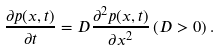Convert formula to latex. <formula><loc_0><loc_0><loc_500><loc_500>\frac { \partial p ( x , t ) } { \partial t } = D \frac { \partial ^ { 2 } p ( x , t ) } { \partial x ^ { 2 } } \, ( D > 0 ) \, .</formula> 